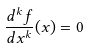Convert formula to latex. <formula><loc_0><loc_0><loc_500><loc_500>\frac { d ^ { k } f } { d x ^ { k } } ( x ) = 0</formula> 